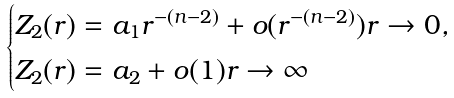Convert formula to latex. <formula><loc_0><loc_0><loc_500><loc_500>\begin{cases} Z _ { 2 } ( r ) = a _ { 1 } r ^ { - ( n - 2 ) } + o ( r ^ { - ( n - 2 ) } ) r \to 0 , \\ Z _ { 2 } ( r ) = a _ { 2 } + o ( 1 ) r \to \infty \end{cases}</formula> 